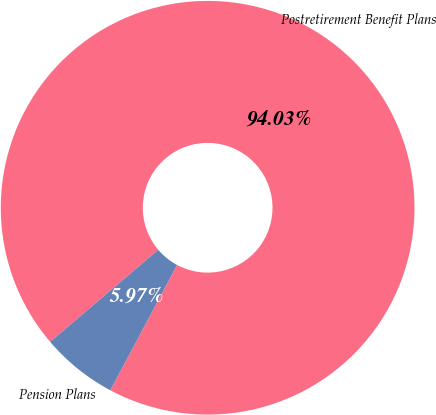<chart> <loc_0><loc_0><loc_500><loc_500><pie_chart><fcel>Postretirement Benefit Plans<fcel>Pension Plans<nl><fcel>94.03%<fcel>5.97%<nl></chart> 